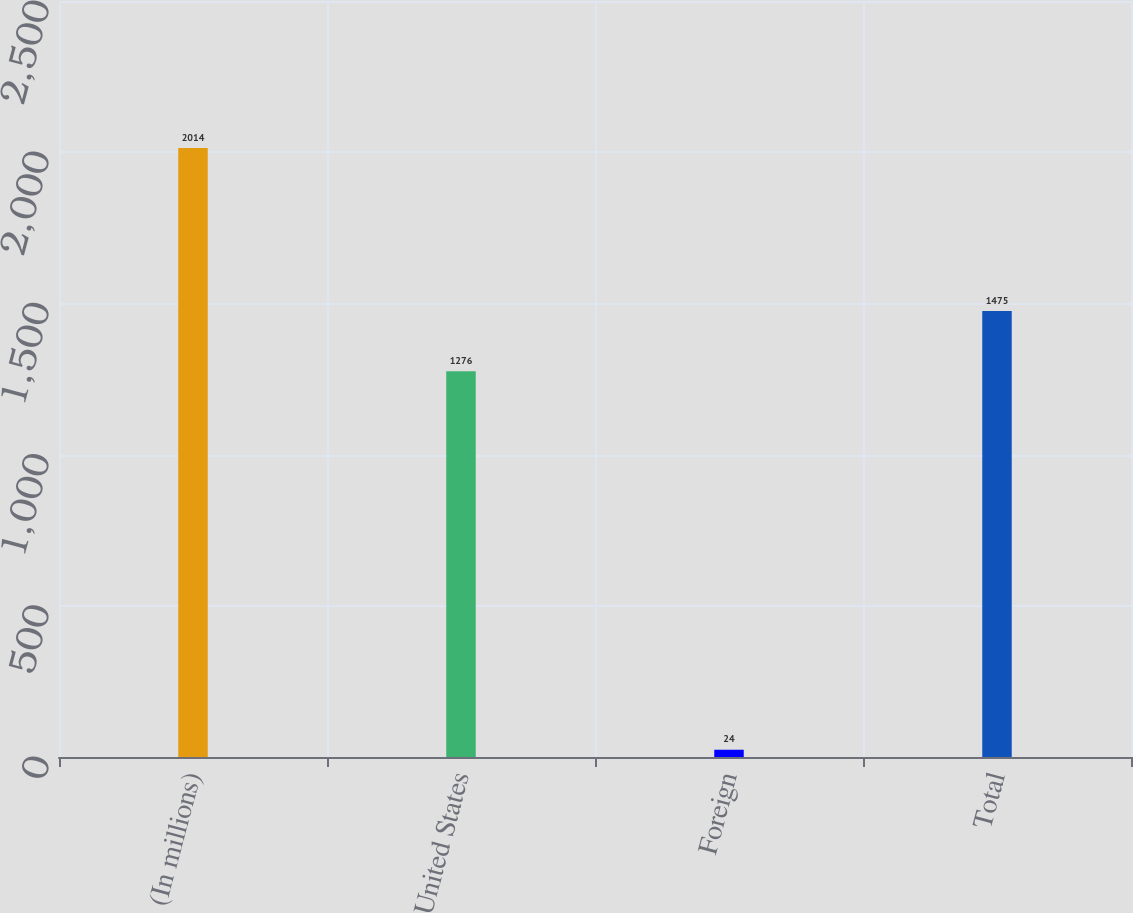Convert chart. <chart><loc_0><loc_0><loc_500><loc_500><bar_chart><fcel>(In millions)<fcel>United States<fcel>Foreign<fcel>Total<nl><fcel>2014<fcel>1276<fcel>24<fcel>1475<nl></chart> 